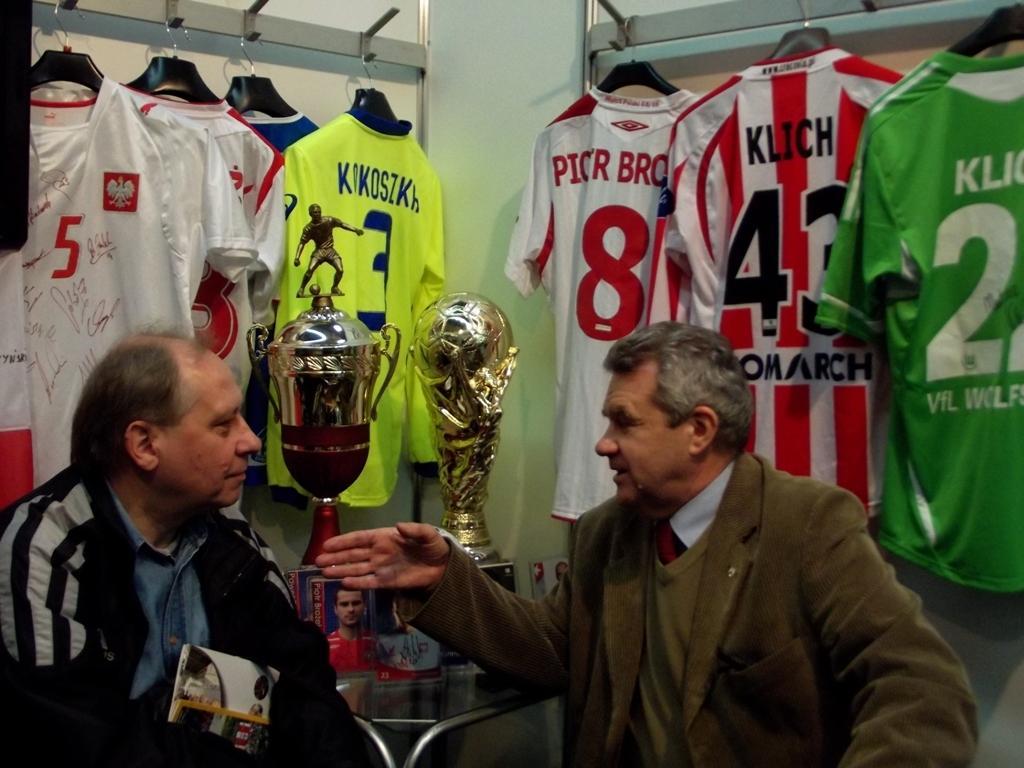<image>
Provide a brief description of the given image. the number 8 is on the back of a jersey 